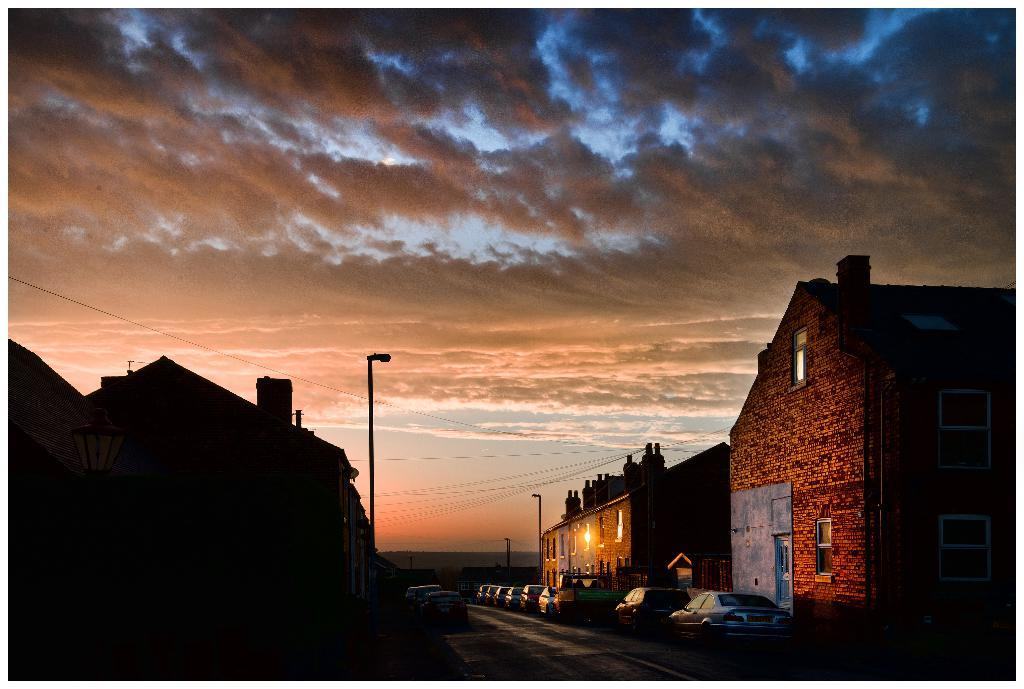What type of vehicles are at the bottom side of the image? There are cars at the bottom side of the image. What structures can be seen on the right side of the image? There are houses on the right side of the image. What structures can be seen on the left side of the image? There are houses on the left side of the image. Can you see a mitten being used by a yak in the image? There is no mitten or yak present in the image. How does the balance of the houses on the left side of the image compare to the houses on the right side of the image? The balance of the houses cannot be compared in the image, as there is no reference point or indication of balance provided. 